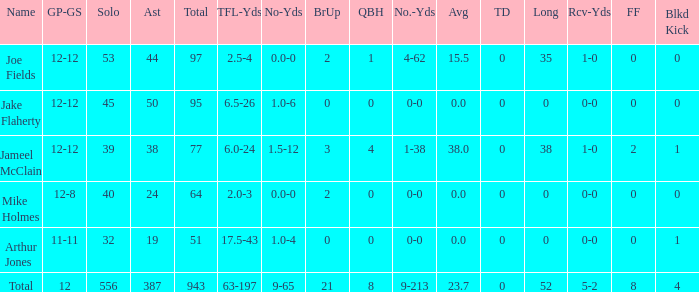What is the maximum number of touchdowns a player has scored? 0.0. 